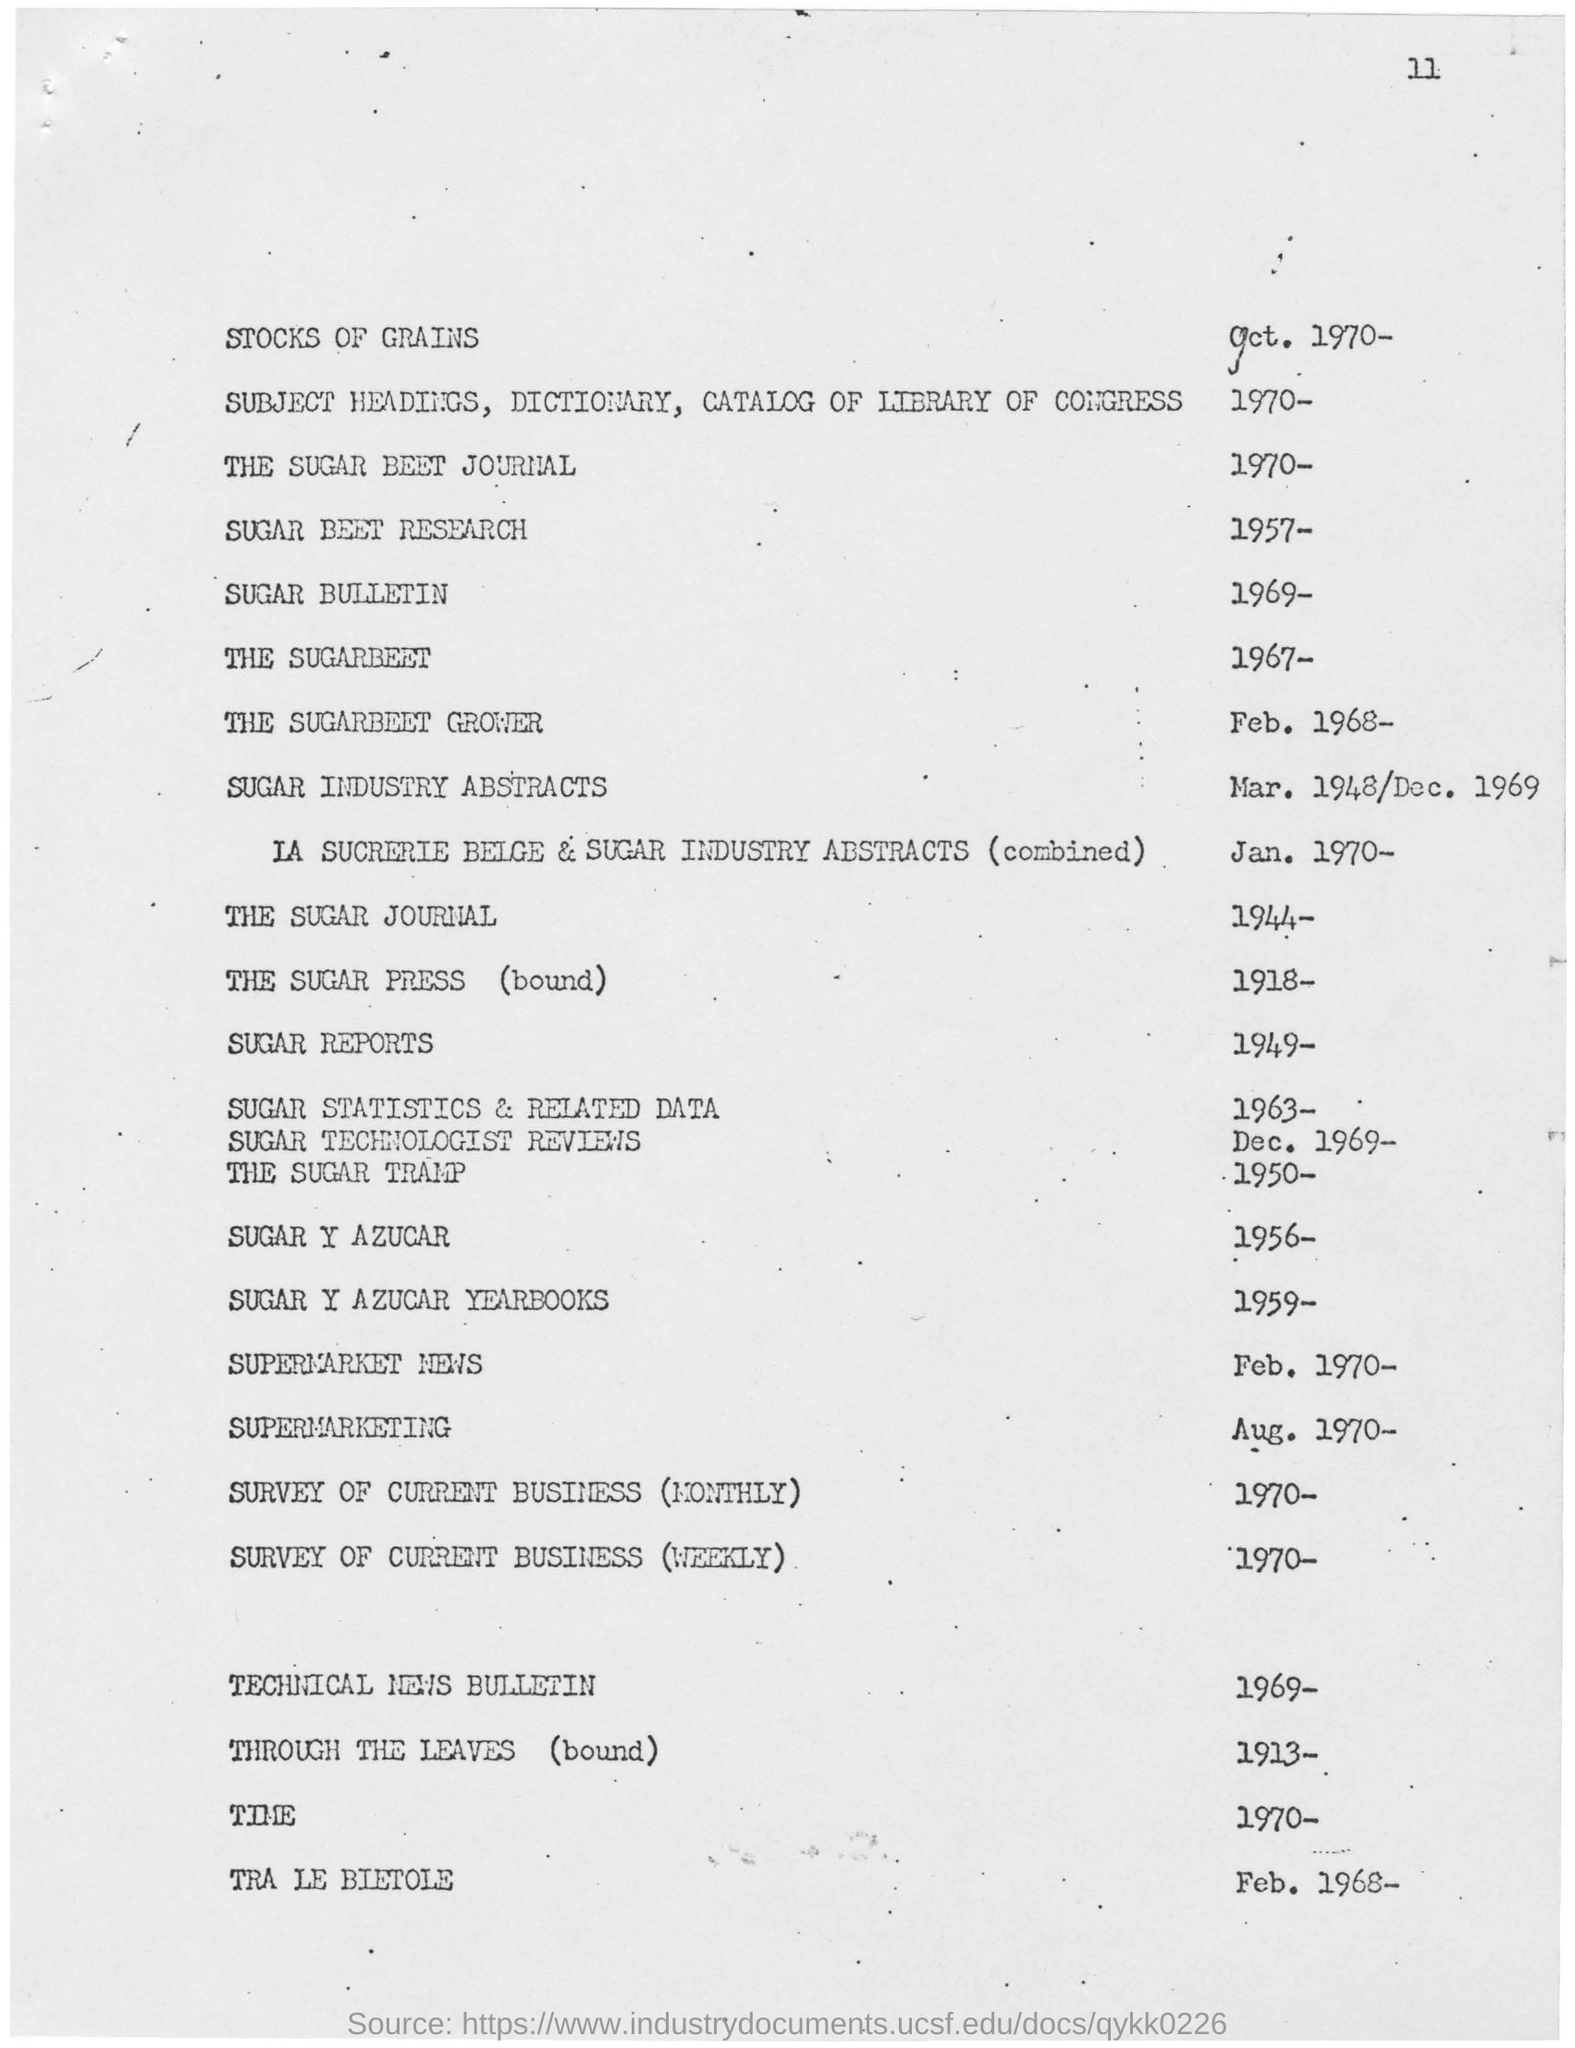Mention a couple of crucial points in this snapshot. The year mentioned in the Sugar Beet Journal is 1970. The year mentioned for the sugar beet grower is February 1968, or possibly later. The year for the sugar beet research is 1957. 